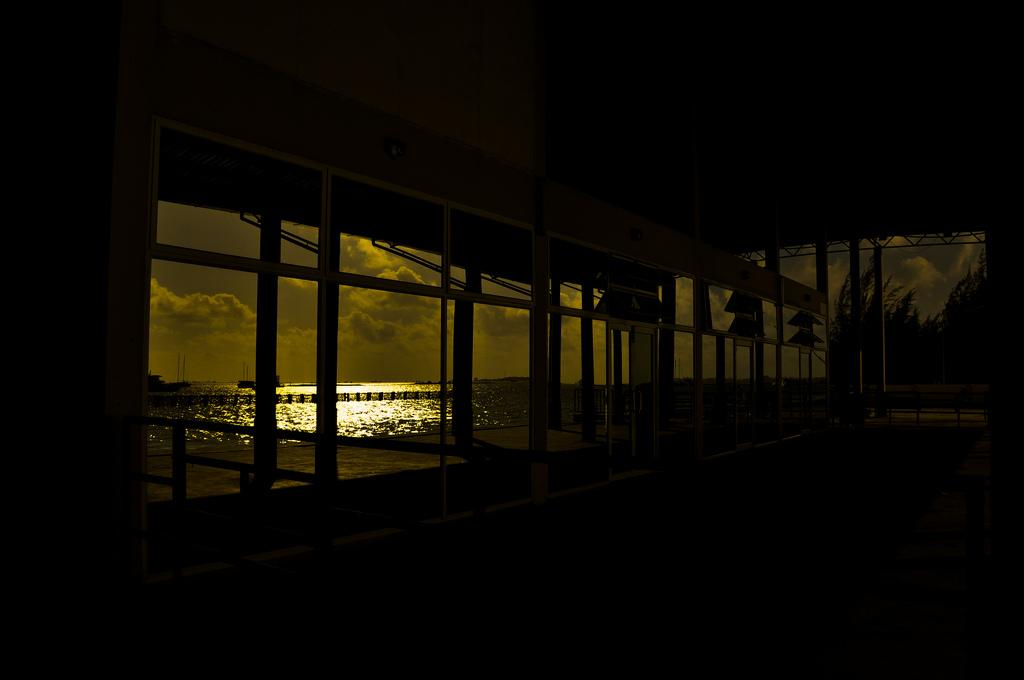What is located in the center of the image? There is a door in the center of the image. What can be seen through the door? The sea is visible through the door. What type of natural environment is visible in the background of the image? There are trees and the sky visible in the background of the image. What is the acoustics like in the image? The provided facts do not give any information about the acoustics in the image, so it cannot be determined. --- 